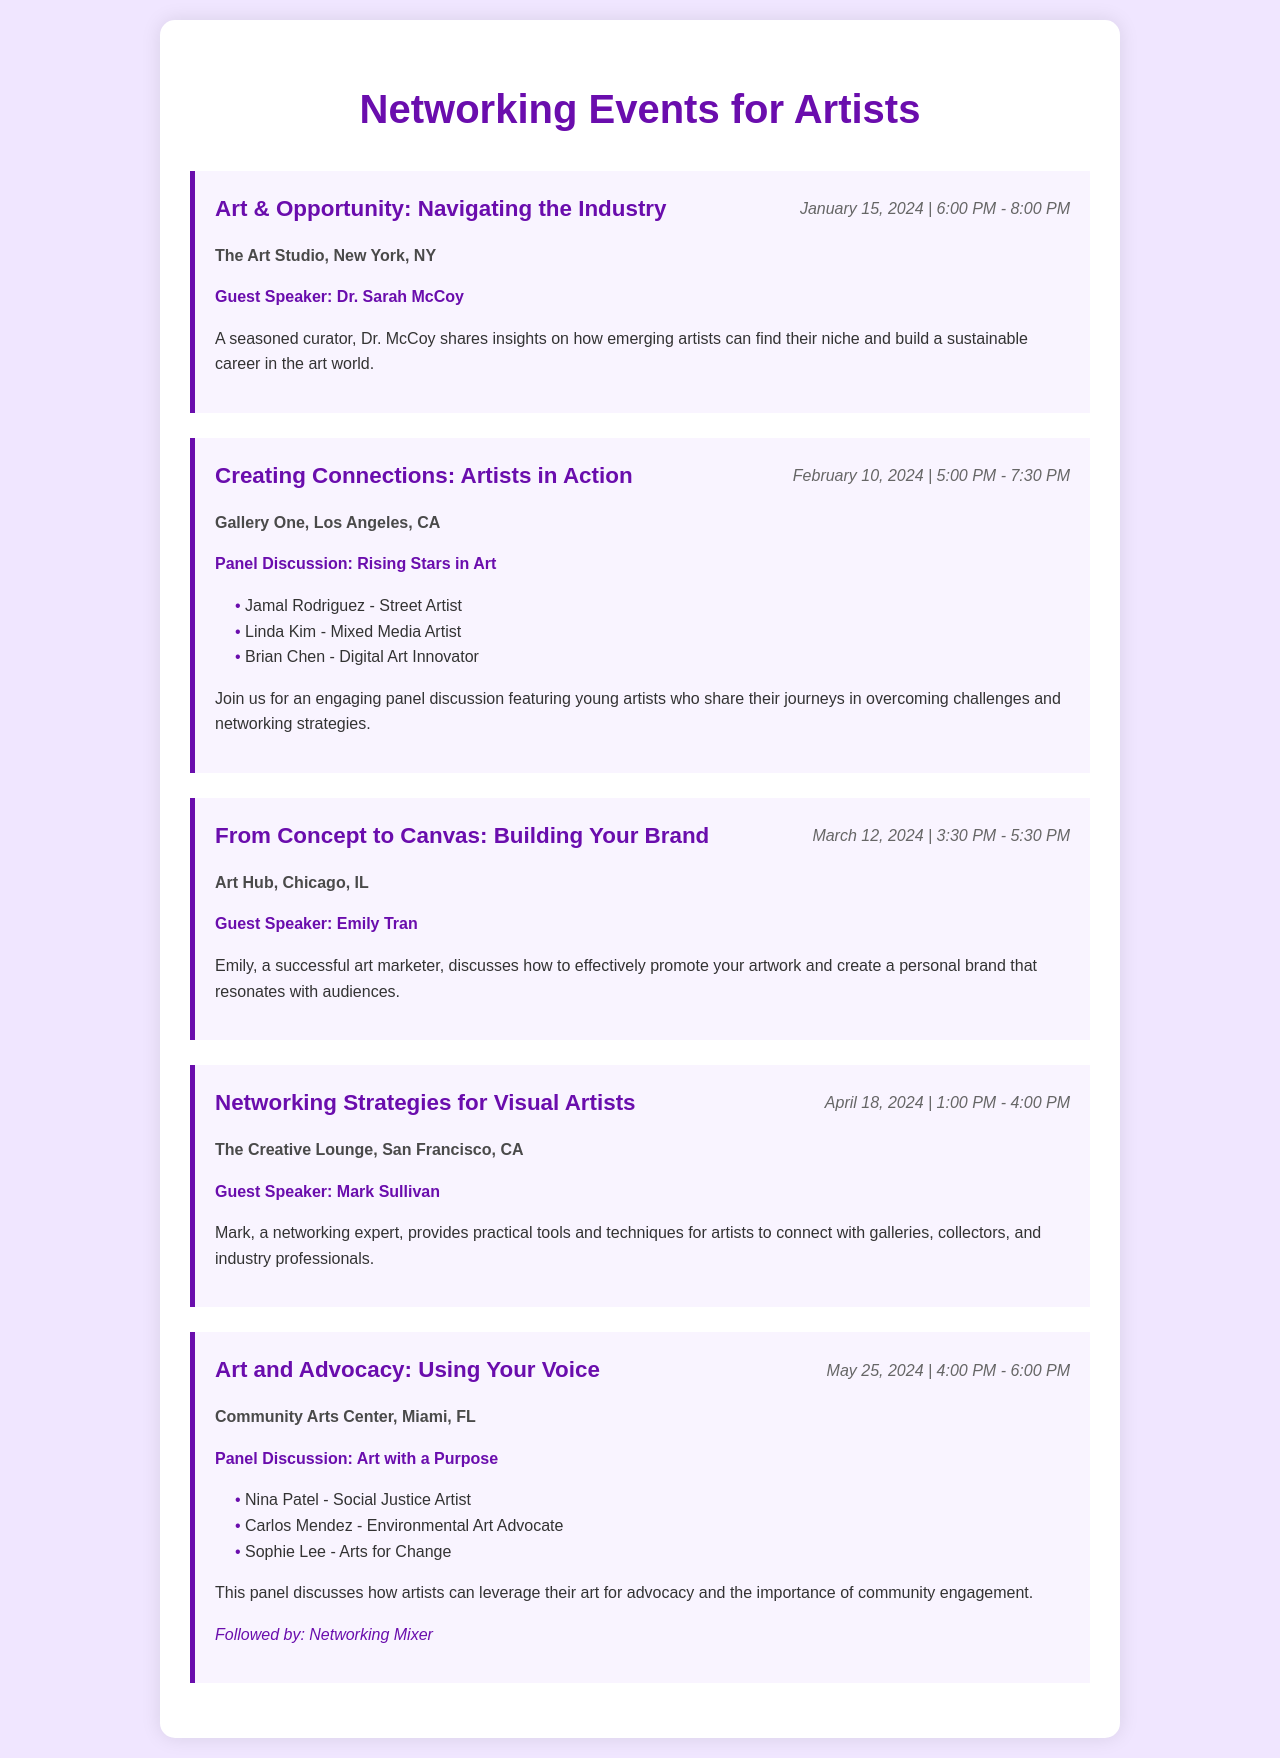What is the title of the first event? The title of the first event is found in the event section and is "Art & Opportunity: Navigating the Industry."
Answer: Art & Opportunity: Navigating the Industry Who is the guest speaker for the event on March 12, 2024? The guest speaker for the March 12, 2024 event is listed in the event description and is "Emily Tran."
Answer: Emily Tran Name one participant from the panel discussion "Art with a Purpose." The participants are listed under the panel discussion, and one of them is "Nina Patel."
Answer: Nina Patel Which city hosts the event "Creating Connections: Artists in Action"? The event's location is provided, identifying the city as "Los Angeles, CA."
Answer: Los Angeles, CA How many events have guest speakers? The presence of guest speakers is noted in different events; they are "Art & Opportunity: Navigating the Industry," "From Concept to Canvas: Building Your Brand," and "Networking Strategies for Visual Artists," totaling three.
Answer: 3 What session follows the panel discussion on May 25, 2024? The session that follows is indicated in the event description as a "Networking Mixer."
Answer: Networking Mixer What is the time duration for the event "From Concept to Canvas: Building Your Brand"? The duration can be calculated from the start and end time provided as "3:30 PM - 5:30 PM," making it a two-hour event.
Answer: 2 hours 